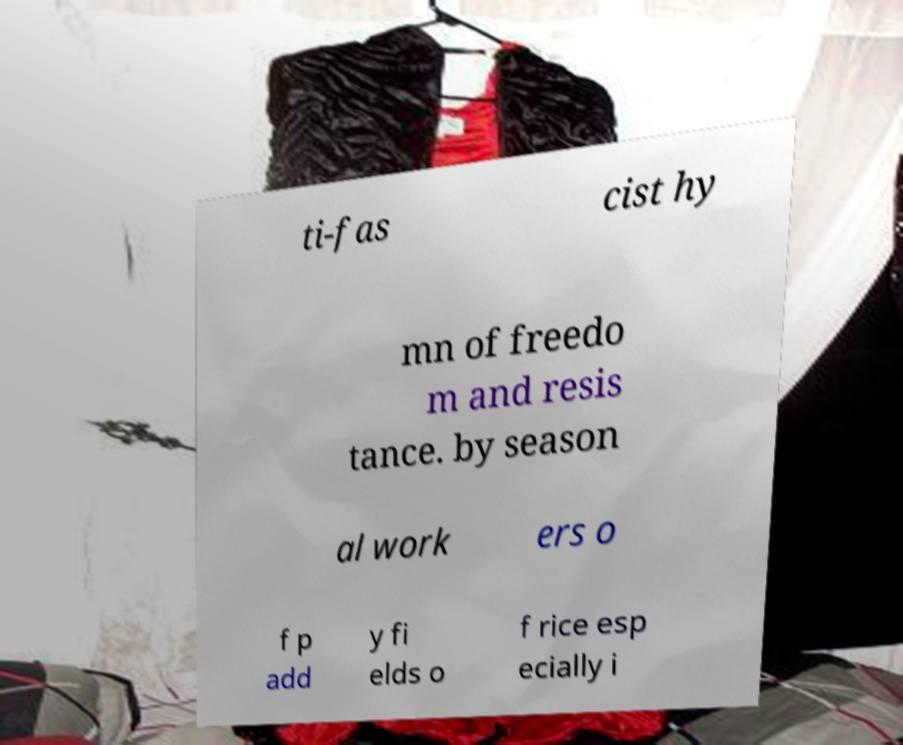Could you assist in decoding the text presented in this image and type it out clearly? ti-fas cist hy mn of freedo m and resis tance. by season al work ers o f p add y fi elds o f rice esp ecially i 